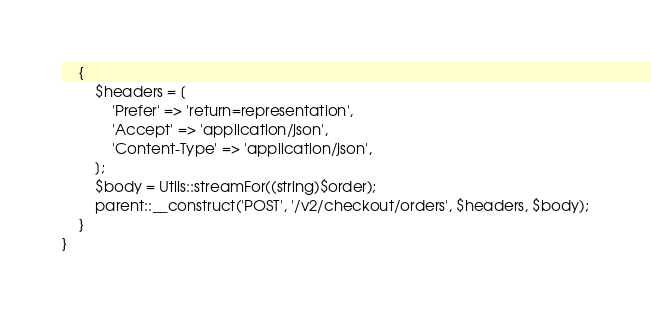Convert code to text. <code><loc_0><loc_0><loc_500><loc_500><_PHP_>    {
        $headers = [
            'Prefer' => 'return=representation',
            'Accept' => 'application/json',
            'Content-Type' => 'application/json',
        ];
        $body = Utils::streamFor((string)$order);
        parent::__construct('POST', '/v2/checkout/orders', $headers, $body);
    }
}
</code> 